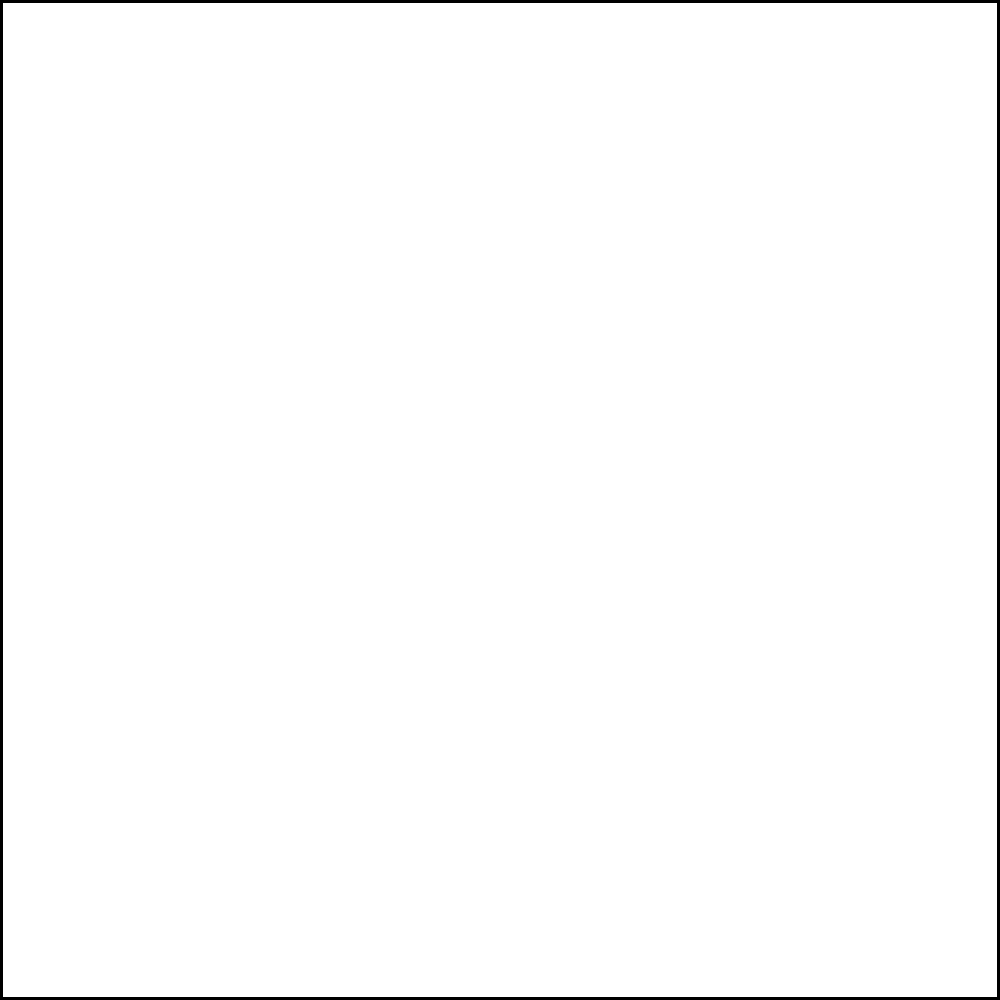In the mixing console layout shown, which channel is typically used for the main kick drum in electronic dance music production, especially in trance tracks inspired by Armin van Buuren? To answer this question, let's consider the standard practices in electronic dance music production, particularly in trance music:

1. Channel arrangement: In most electronic music setups, channels are arranged from left to right in order of importance or frequency range.

2. Kick drum importance: The kick drum is a crucial element in trance music, providing the main driving force of the track.

3. Frequency considerations: The kick drum occupies the lowest frequency range in the mix.

4. Mixing workflow: Producers often place the most important elements on the leftmost channels for easy access.

5. Armin van Buuren's style: In trance music, especially in Armin van Buuren's tracks, the kick drum is prominently featured and carefully mixed.

6. Console layout: In the given image, we see 8 channels represented by vertical faders.

7. Highlighted channel: The third channel from the left is highlighted in red and marked with an "X".

8. Standard practice: The kick drum is typically placed on one of the first channels, often the first or second, due to its importance.

9. Conclusion: Given the highlighted third channel, we can infer that this is likely the designated channel for the kick drum in this particular setup.
Answer: Channel 3 (the highlighted channel) 